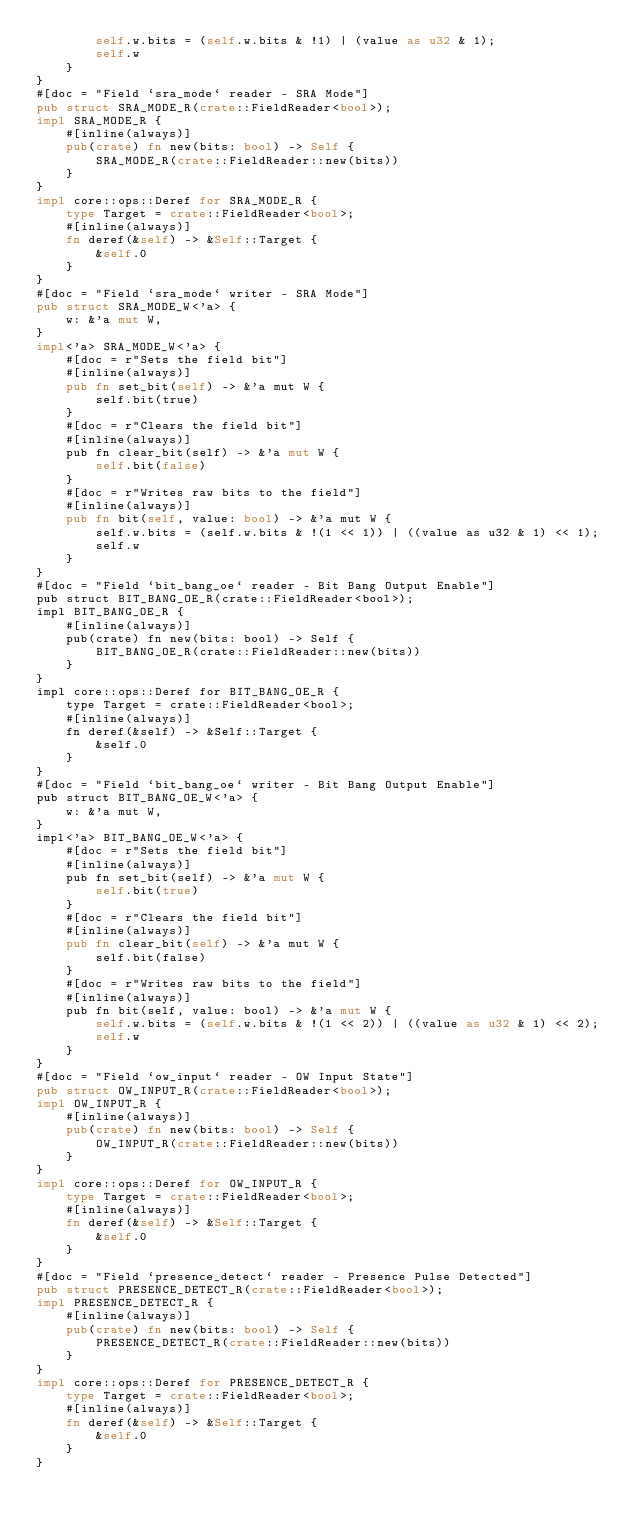Convert code to text. <code><loc_0><loc_0><loc_500><loc_500><_Rust_>        self.w.bits = (self.w.bits & !1) | (value as u32 & 1);
        self.w
    }
}
#[doc = "Field `sra_mode` reader - SRA Mode"]
pub struct SRA_MODE_R(crate::FieldReader<bool>);
impl SRA_MODE_R {
    #[inline(always)]
    pub(crate) fn new(bits: bool) -> Self {
        SRA_MODE_R(crate::FieldReader::new(bits))
    }
}
impl core::ops::Deref for SRA_MODE_R {
    type Target = crate::FieldReader<bool>;
    #[inline(always)]
    fn deref(&self) -> &Self::Target {
        &self.0
    }
}
#[doc = "Field `sra_mode` writer - SRA Mode"]
pub struct SRA_MODE_W<'a> {
    w: &'a mut W,
}
impl<'a> SRA_MODE_W<'a> {
    #[doc = r"Sets the field bit"]
    #[inline(always)]
    pub fn set_bit(self) -> &'a mut W {
        self.bit(true)
    }
    #[doc = r"Clears the field bit"]
    #[inline(always)]
    pub fn clear_bit(self) -> &'a mut W {
        self.bit(false)
    }
    #[doc = r"Writes raw bits to the field"]
    #[inline(always)]
    pub fn bit(self, value: bool) -> &'a mut W {
        self.w.bits = (self.w.bits & !(1 << 1)) | ((value as u32 & 1) << 1);
        self.w
    }
}
#[doc = "Field `bit_bang_oe` reader - Bit Bang Output Enable"]
pub struct BIT_BANG_OE_R(crate::FieldReader<bool>);
impl BIT_BANG_OE_R {
    #[inline(always)]
    pub(crate) fn new(bits: bool) -> Self {
        BIT_BANG_OE_R(crate::FieldReader::new(bits))
    }
}
impl core::ops::Deref for BIT_BANG_OE_R {
    type Target = crate::FieldReader<bool>;
    #[inline(always)]
    fn deref(&self) -> &Self::Target {
        &self.0
    }
}
#[doc = "Field `bit_bang_oe` writer - Bit Bang Output Enable"]
pub struct BIT_BANG_OE_W<'a> {
    w: &'a mut W,
}
impl<'a> BIT_BANG_OE_W<'a> {
    #[doc = r"Sets the field bit"]
    #[inline(always)]
    pub fn set_bit(self) -> &'a mut W {
        self.bit(true)
    }
    #[doc = r"Clears the field bit"]
    #[inline(always)]
    pub fn clear_bit(self) -> &'a mut W {
        self.bit(false)
    }
    #[doc = r"Writes raw bits to the field"]
    #[inline(always)]
    pub fn bit(self, value: bool) -> &'a mut W {
        self.w.bits = (self.w.bits & !(1 << 2)) | ((value as u32 & 1) << 2);
        self.w
    }
}
#[doc = "Field `ow_input` reader - OW Input State"]
pub struct OW_INPUT_R(crate::FieldReader<bool>);
impl OW_INPUT_R {
    #[inline(always)]
    pub(crate) fn new(bits: bool) -> Self {
        OW_INPUT_R(crate::FieldReader::new(bits))
    }
}
impl core::ops::Deref for OW_INPUT_R {
    type Target = crate::FieldReader<bool>;
    #[inline(always)]
    fn deref(&self) -> &Self::Target {
        &self.0
    }
}
#[doc = "Field `presence_detect` reader - Presence Pulse Detected"]
pub struct PRESENCE_DETECT_R(crate::FieldReader<bool>);
impl PRESENCE_DETECT_R {
    #[inline(always)]
    pub(crate) fn new(bits: bool) -> Self {
        PRESENCE_DETECT_R(crate::FieldReader::new(bits))
    }
}
impl core::ops::Deref for PRESENCE_DETECT_R {
    type Target = crate::FieldReader<bool>;
    #[inline(always)]
    fn deref(&self) -> &Self::Target {
        &self.0
    }
}</code> 